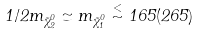<formula> <loc_0><loc_0><loc_500><loc_500>1 / 2 m _ { \tilde { \chi } ^ { 0 } _ { 2 } } \simeq m _ { \tilde { \chi } ^ { 0 } _ { 1 } } \stackrel { < } { \sim } 1 6 5 ( 2 6 5 )</formula> 